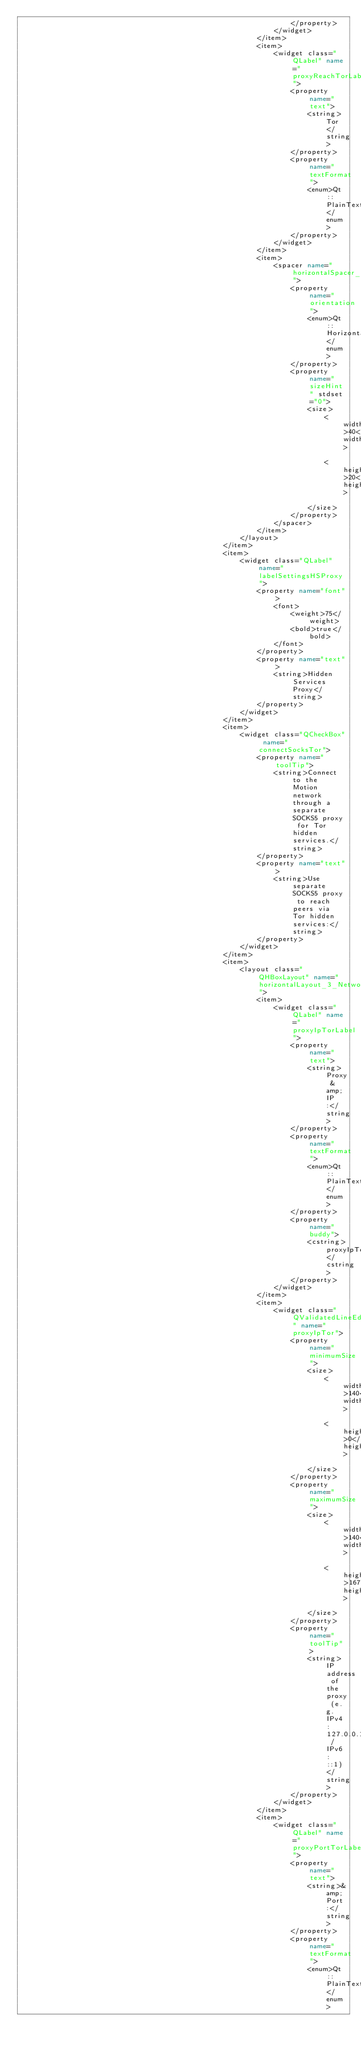<code> <loc_0><loc_0><loc_500><loc_500><_XML_>                                                                </property>
                                                            </widget>
                                                        </item>
                                                        <item>
                                                            <widget class="QLabel" name="proxyReachTorLabel">
                                                                <property name="text">
                                                                    <string>Tor</string>
                                                                </property>
                                                                <property name="textFormat">
                                                                    <enum>Qt::PlainText</enum>
                                                                </property>
                                                            </widget>
                                                        </item>
                                                        <item>
                                                            <spacer name="horizontalSpacer_2_Network">
                                                                <property name="orientation">
                                                                    <enum>Qt::Horizontal</enum>
                                                                </property>
                                                                <property name="sizeHint" stdset="0">
                                                                    <size>
                                                                        <width>40</width>
                                                                        <height>20</height>
                                                                    </size>
                                                                </property>
                                                            </spacer>
                                                        </item>
                                                    </layout>
                                                </item>
                                                <item>
                                                    <widget class="QLabel" name="labelSettingsHSProxy">
                                                        <property name="font">
                                                            <font>
                                                                <weight>75</weight>
                                                                <bold>true</bold>
                                                            </font>
                                                        </property>
                                                        <property name="text">
                                                            <string>Hidden Services Proxy</string>
                                                        </property>
                                                    </widget>
                                                </item>
                                                <item>
                                                    <widget class="QCheckBox" name="connectSocksTor">
                                                        <property name="toolTip">
                                                            <string>Connect to the Motion network through a separate SOCKS5 proxy for Tor hidden services.</string>
                                                        </property>
                                                        <property name="text">
                                                            <string>Use separate SOCKS5 proxy to reach peers via Tor hidden services:</string>
                                                        </property>
                                                    </widget>
                                                </item>
                                                <item>
                                                    <layout class="QHBoxLayout" name="horizontalLayout_3_Network">
                                                        <item>
                                                            <widget class="QLabel" name="proxyIpTorLabel">
                                                                <property name="text">
                                                                    <string>Proxy &amp;IP:</string>
                                                                </property>
                                                                <property name="textFormat">
                                                                    <enum>Qt::PlainText</enum>
                                                                </property>
                                                                <property name="buddy">
                                                                    <cstring>proxyIpTor</cstring>
                                                                </property>
                                                            </widget>
                                                        </item>
                                                        <item>
                                                            <widget class="QValidatedLineEdit" name="proxyIpTor">
                                                                <property name="minimumSize">
                                                                    <size>
                                                                        <width>140</width>
                                                                        <height>0</height>
                                                                    </size>
                                                                </property>
                                                                <property name="maximumSize">
                                                                    <size>
                                                                        <width>140</width>
                                                                        <height>16777215</height>
                                                                    </size>
                                                                </property>
                                                                <property name="toolTip">
                                                                    <string>IP address of the proxy (e.g. IPv4: 127.0.0.1 / IPv6: ::1)</string>
                                                                </property>
                                                            </widget>
                                                        </item>
                                                        <item>
                                                            <widget class="QLabel" name="proxyPortTorLabel">
                                                                <property name="text">
                                                                    <string>&amp;Port:</string>
                                                                </property>
                                                                <property name="textFormat">
                                                                    <enum>Qt::PlainText</enum></code> 